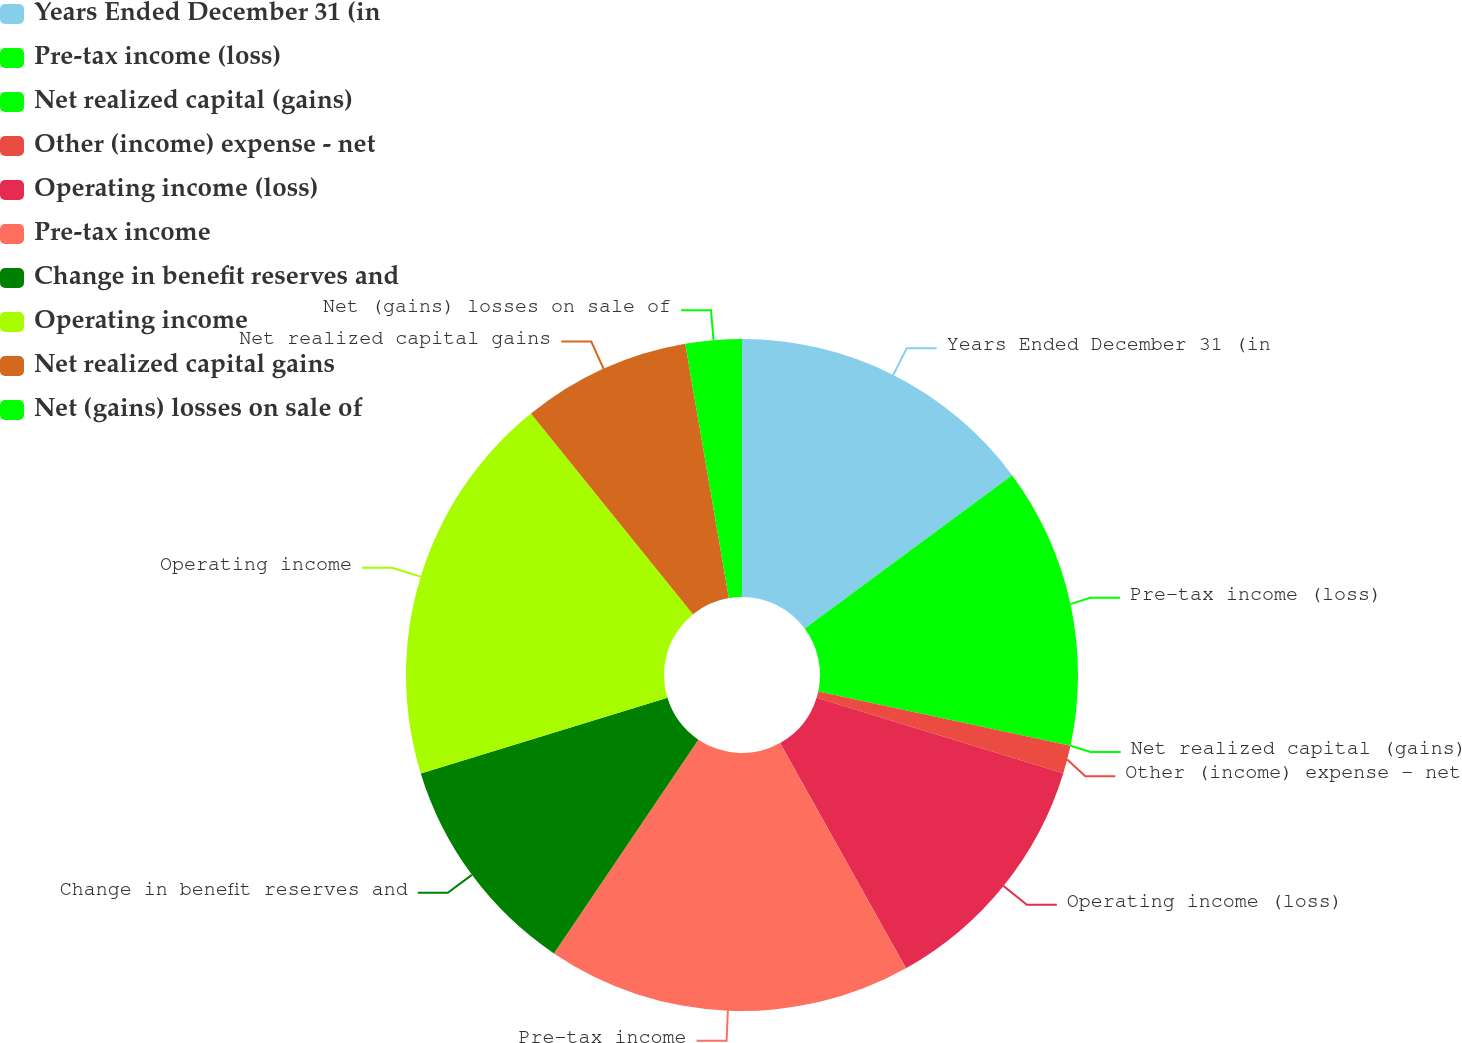Convert chart to OTSL. <chart><loc_0><loc_0><loc_500><loc_500><pie_chart><fcel>Years Ended December 31 (in<fcel>Pre-tax income (loss)<fcel>Net realized capital (gains)<fcel>Other (income) expense - net<fcel>Operating income (loss)<fcel>Pre-tax income<fcel>Change in benefit reserves and<fcel>Operating income<fcel>Net realized capital gains<fcel>Net (gains) losses on sale of<nl><fcel>14.86%<fcel>13.51%<fcel>0.0%<fcel>1.35%<fcel>12.16%<fcel>17.57%<fcel>10.81%<fcel>18.92%<fcel>8.11%<fcel>2.7%<nl></chart> 